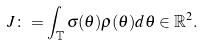<formula> <loc_0><loc_0><loc_500><loc_500>J \colon = \int _ { \mathbb { T } } \sigma ( \theta ) \rho ( \theta ) d \theta \in \mathbb { R } ^ { 2 } .</formula> 